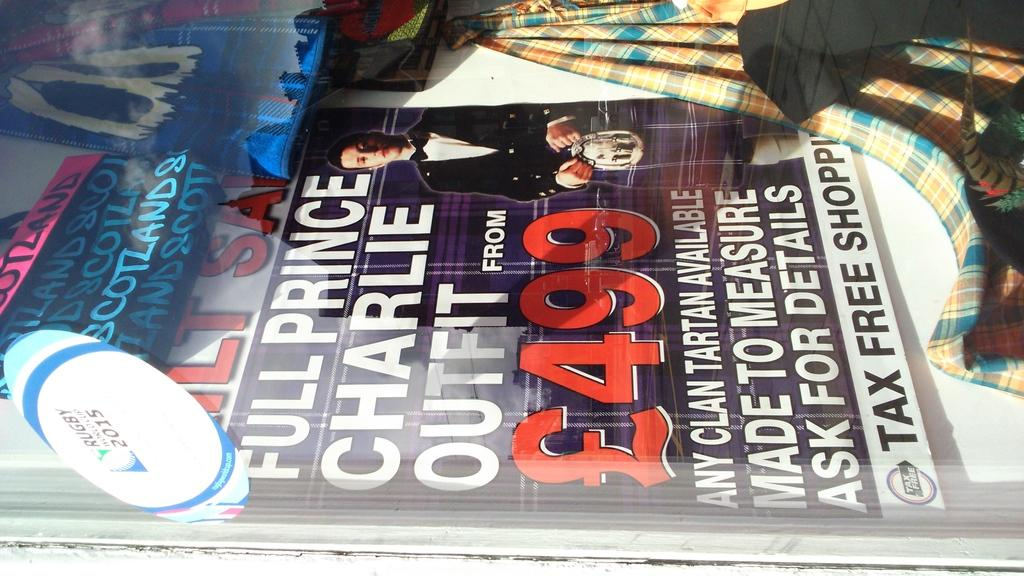<image>
Give a short and clear explanation of the subsequent image. Magazine cover showing a man and something that costs 499. 